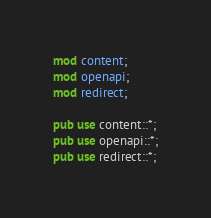Convert code to text. <code><loc_0><loc_0><loc_500><loc_500><_Rust_>mod content;
mod openapi;
mod redirect;

pub use content::*;
pub use openapi::*;
pub use redirect::*;
</code> 